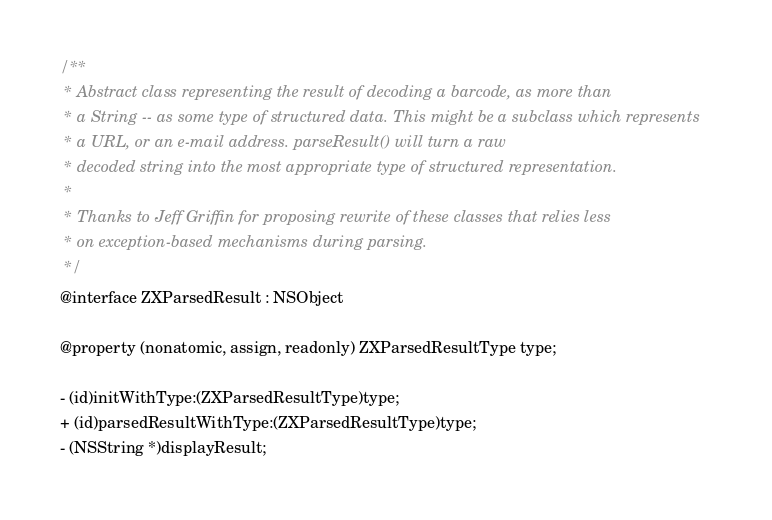Convert code to text. <code><loc_0><loc_0><loc_500><loc_500><_C_>
/**
 * Abstract class representing the result of decoding a barcode, as more than
 * a String -- as some type of structured data. This might be a subclass which represents
 * a URL, or an e-mail address. parseResult() will turn a raw
 * decoded string into the most appropriate type of structured representation.
 *
 * Thanks to Jeff Griffin for proposing rewrite of these classes that relies less
 * on exception-based mechanisms during parsing.
 */
@interface ZXParsedResult : NSObject

@property (nonatomic, assign, readonly) ZXParsedResultType type;

- (id)initWithType:(ZXParsedResultType)type;
+ (id)parsedResultWithType:(ZXParsedResultType)type;
- (NSString *)displayResult;</code> 